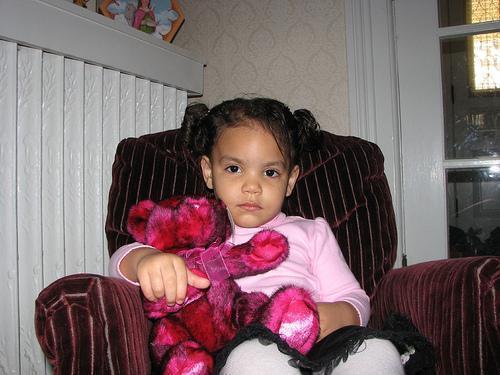How many chairs are there?
Give a very brief answer. 1. 